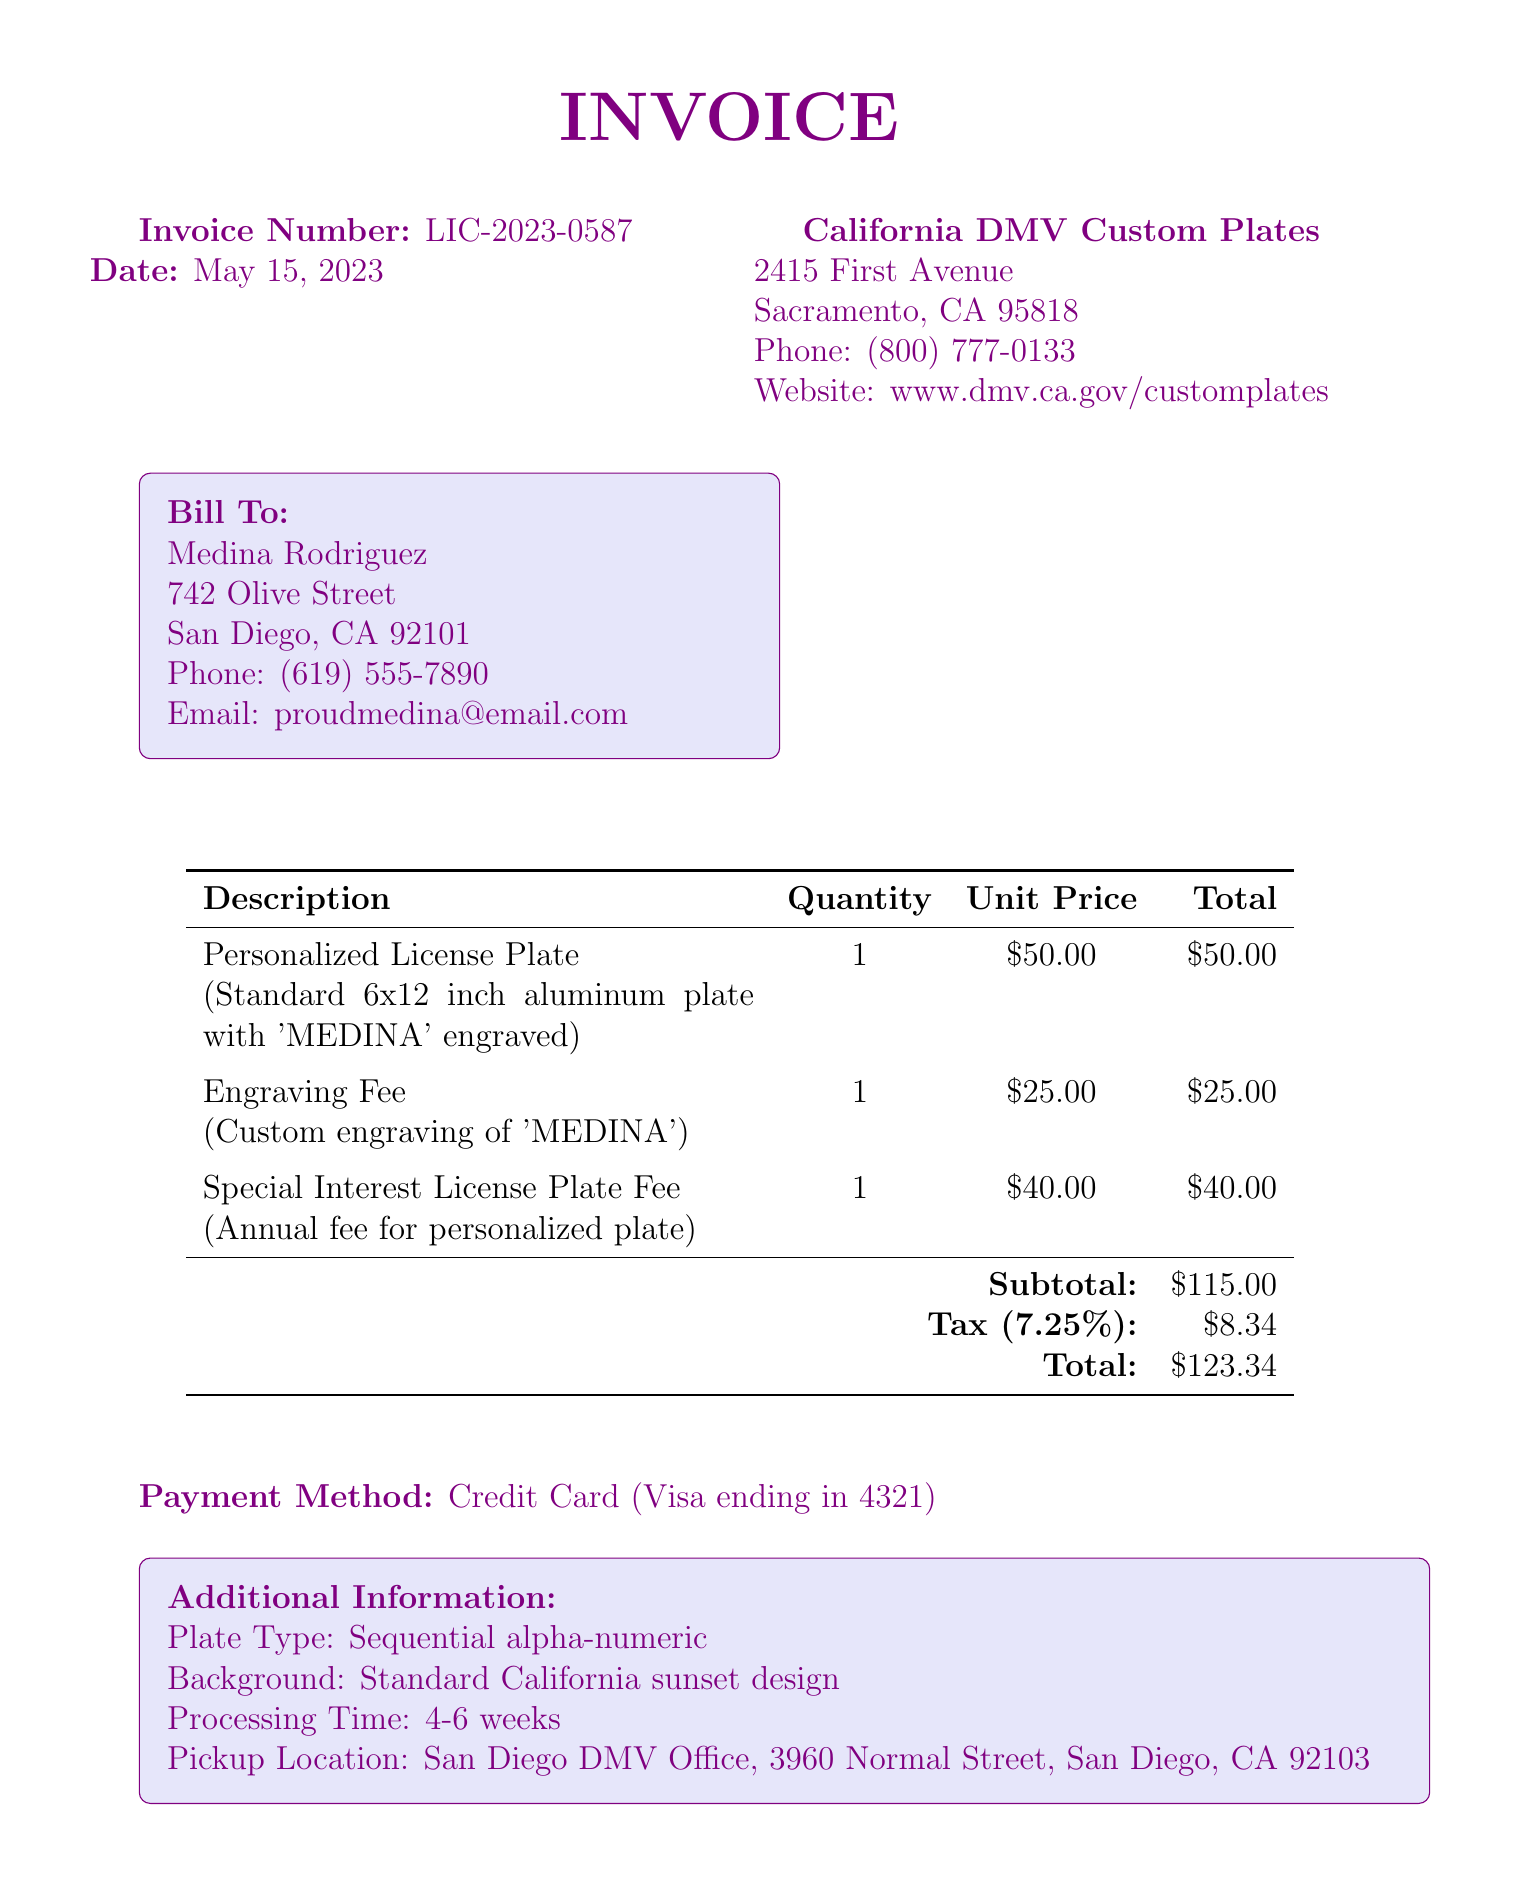What is the invoice number? The invoice number is a unique identifier for this purchase, found in the document.
Answer: LIC-2023-0587 What is the date of the invoice? The date indicates when the invoice was generated and is clearly stated in the document.
Answer: May 15, 2023 Who is the customer? The customer section contains the name of the individual who made the purchase, providing basic identification.
Answer: Medina Rodriguez What is the total amount due? The total amount due is the final figure that includes all costs and taxes, located in the document.
Answer: $123.34 What is the description of the personalized license plate? The description provides details about the item purchased, which is found under order details.
Answer: Standard 6x12 inch aluminum plate with 'MEDINA' engraved What is the tax amount? The tax amount is calculated based on the subtotal and tax rate, as listed in the invoice.
Answer: $8.34 What is the payment method? The payment method indicates how the customer paid for the service and is specified in the document.
Answer: Credit Card (Visa ending in 4321) How long is the processing time? The processing time gives an estimate of when the license plate will be ready and is mentioned in the additional information section.
Answer: 4-6 weeks What should Medina remember regarding the license plate? This note is an important reminder regarding the maintenance or renewal of the personalized plate, stated in the notes section.
Answer: Renew annualy 